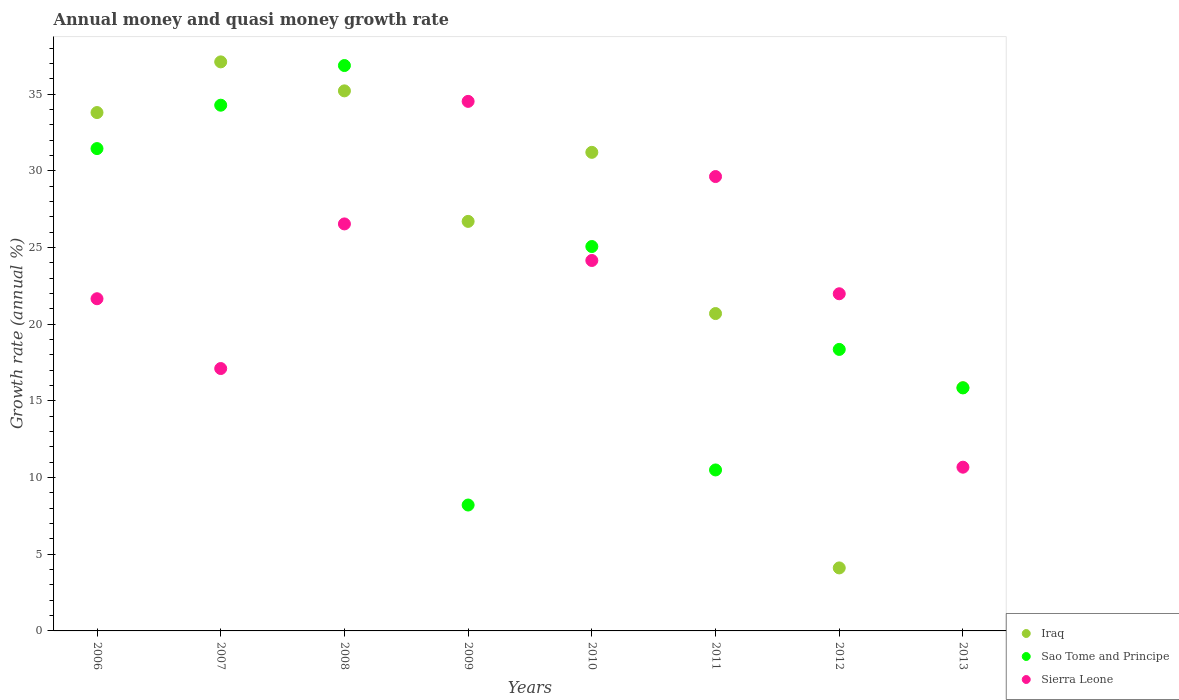Is the number of dotlines equal to the number of legend labels?
Offer a very short reply. Yes. What is the growth rate in Sierra Leone in 2006?
Your answer should be very brief. 21.66. Across all years, what is the maximum growth rate in Iraq?
Your response must be concise. 37.11. Across all years, what is the minimum growth rate in Sao Tome and Principe?
Keep it short and to the point. 8.21. In which year was the growth rate in Sao Tome and Principe maximum?
Keep it short and to the point. 2008. What is the total growth rate in Iraq in the graph?
Make the answer very short. 204.7. What is the difference between the growth rate in Sao Tome and Principe in 2007 and that in 2010?
Your response must be concise. 9.22. What is the difference between the growth rate in Sierra Leone in 2006 and the growth rate in Sao Tome and Principe in 2009?
Your answer should be very brief. 13.45. What is the average growth rate in Iraq per year?
Offer a terse response. 25.59. In the year 2011, what is the difference between the growth rate in Sierra Leone and growth rate in Iraq?
Your answer should be very brief. 8.93. In how many years, is the growth rate in Iraq greater than 10 %?
Make the answer very short. 7. What is the ratio of the growth rate in Iraq in 2008 to that in 2011?
Provide a succinct answer. 1.7. What is the difference between the highest and the second highest growth rate in Sierra Leone?
Make the answer very short. 4.9. What is the difference between the highest and the lowest growth rate in Iraq?
Give a very brief answer. 33. In how many years, is the growth rate in Sierra Leone greater than the average growth rate in Sierra Leone taken over all years?
Your response must be concise. 4. Is the sum of the growth rate in Iraq in 2008 and 2010 greater than the maximum growth rate in Sao Tome and Principe across all years?
Provide a short and direct response. Yes. Is it the case that in every year, the sum of the growth rate in Sierra Leone and growth rate in Sao Tome and Principe  is greater than the growth rate in Iraq?
Keep it short and to the point. Yes. Does the growth rate in Iraq monotonically increase over the years?
Provide a short and direct response. No. How many dotlines are there?
Your response must be concise. 3. Are the values on the major ticks of Y-axis written in scientific E-notation?
Your response must be concise. No. Does the graph contain grids?
Ensure brevity in your answer.  No. How are the legend labels stacked?
Your answer should be compact. Vertical. What is the title of the graph?
Provide a short and direct response. Annual money and quasi money growth rate. Does "Euro area" appear as one of the legend labels in the graph?
Give a very brief answer. No. What is the label or title of the X-axis?
Your answer should be compact. Years. What is the label or title of the Y-axis?
Offer a very short reply. Growth rate (annual %). What is the Growth rate (annual %) in Iraq in 2006?
Your answer should be compact. 33.8. What is the Growth rate (annual %) in Sao Tome and Principe in 2006?
Your response must be concise. 31.45. What is the Growth rate (annual %) in Sierra Leone in 2006?
Make the answer very short. 21.66. What is the Growth rate (annual %) of Iraq in 2007?
Offer a very short reply. 37.11. What is the Growth rate (annual %) of Sao Tome and Principe in 2007?
Give a very brief answer. 34.28. What is the Growth rate (annual %) in Sierra Leone in 2007?
Offer a very short reply. 17.11. What is the Growth rate (annual %) in Iraq in 2008?
Your response must be concise. 35.22. What is the Growth rate (annual %) in Sao Tome and Principe in 2008?
Your answer should be very brief. 36.87. What is the Growth rate (annual %) in Sierra Leone in 2008?
Offer a very short reply. 26.54. What is the Growth rate (annual %) in Iraq in 2009?
Provide a succinct answer. 26.7. What is the Growth rate (annual %) of Sao Tome and Principe in 2009?
Your answer should be compact. 8.21. What is the Growth rate (annual %) in Sierra Leone in 2009?
Offer a terse response. 34.53. What is the Growth rate (annual %) in Iraq in 2010?
Provide a succinct answer. 31.21. What is the Growth rate (annual %) of Sao Tome and Principe in 2010?
Make the answer very short. 25.06. What is the Growth rate (annual %) in Sierra Leone in 2010?
Offer a very short reply. 24.15. What is the Growth rate (annual %) of Iraq in 2011?
Provide a short and direct response. 20.69. What is the Growth rate (annual %) in Sao Tome and Principe in 2011?
Your answer should be very brief. 10.5. What is the Growth rate (annual %) in Sierra Leone in 2011?
Make the answer very short. 29.63. What is the Growth rate (annual %) of Iraq in 2012?
Offer a terse response. 4.11. What is the Growth rate (annual %) of Sao Tome and Principe in 2012?
Offer a very short reply. 18.36. What is the Growth rate (annual %) of Sierra Leone in 2012?
Your answer should be compact. 21.98. What is the Growth rate (annual %) of Iraq in 2013?
Give a very brief answer. 15.86. What is the Growth rate (annual %) in Sao Tome and Principe in 2013?
Make the answer very short. 15.85. What is the Growth rate (annual %) of Sierra Leone in 2013?
Your answer should be very brief. 10.68. Across all years, what is the maximum Growth rate (annual %) in Iraq?
Your answer should be very brief. 37.11. Across all years, what is the maximum Growth rate (annual %) of Sao Tome and Principe?
Give a very brief answer. 36.87. Across all years, what is the maximum Growth rate (annual %) of Sierra Leone?
Provide a short and direct response. 34.53. Across all years, what is the minimum Growth rate (annual %) of Iraq?
Give a very brief answer. 4.11. Across all years, what is the minimum Growth rate (annual %) of Sao Tome and Principe?
Offer a terse response. 8.21. Across all years, what is the minimum Growth rate (annual %) of Sierra Leone?
Your answer should be compact. 10.68. What is the total Growth rate (annual %) in Iraq in the graph?
Give a very brief answer. 204.7. What is the total Growth rate (annual %) of Sao Tome and Principe in the graph?
Your answer should be compact. 180.57. What is the total Growth rate (annual %) in Sierra Leone in the graph?
Your answer should be very brief. 186.28. What is the difference between the Growth rate (annual %) of Iraq in 2006 and that in 2007?
Your answer should be very brief. -3.3. What is the difference between the Growth rate (annual %) in Sao Tome and Principe in 2006 and that in 2007?
Your answer should be compact. -2.83. What is the difference between the Growth rate (annual %) of Sierra Leone in 2006 and that in 2007?
Provide a short and direct response. 4.55. What is the difference between the Growth rate (annual %) in Iraq in 2006 and that in 2008?
Ensure brevity in your answer.  -1.41. What is the difference between the Growth rate (annual %) in Sao Tome and Principe in 2006 and that in 2008?
Offer a terse response. -5.42. What is the difference between the Growth rate (annual %) of Sierra Leone in 2006 and that in 2008?
Your answer should be very brief. -4.88. What is the difference between the Growth rate (annual %) of Iraq in 2006 and that in 2009?
Provide a succinct answer. 7.1. What is the difference between the Growth rate (annual %) of Sao Tome and Principe in 2006 and that in 2009?
Provide a short and direct response. 23.24. What is the difference between the Growth rate (annual %) in Sierra Leone in 2006 and that in 2009?
Offer a very short reply. -12.87. What is the difference between the Growth rate (annual %) in Iraq in 2006 and that in 2010?
Make the answer very short. 2.59. What is the difference between the Growth rate (annual %) in Sao Tome and Principe in 2006 and that in 2010?
Offer a very short reply. 6.39. What is the difference between the Growth rate (annual %) of Sierra Leone in 2006 and that in 2010?
Provide a short and direct response. -2.49. What is the difference between the Growth rate (annual %) in Iraq in 2006 and that in 2011?
Provide a succinct answer. 13.11. What is the difference between the Growth rate (annual %) in Sao Tome and Principe in 2006 and that in 2011?
Provide a succinct answer. 20.95. What is the difference between the Growth rate (annual %) in Sierra Leone in 2006 and that in 2011?
Provide a short and direct response. -7.97. What is the difference between the Growth rate (annual %) in Iraq in 2006 and that in 2012?
Your answer should be compact. 29.69. What is the difference between the Growth rate (annual %) in Sao Tome and Principe in 2006 and that in 2012?
Give a very brief answer. 13.1. What is the difference between the Growth rate (annual %) of Sierra Leone in 2006 and that in 2012?
Provide a short and direct response. -0.32. What is the difference between the Growth rate (annual %) in Iraq in 2006 and that in 2013?
Provide a succinct answer. 17.94. What is the difference between the Growth rate (annual %) of Sao Tome and Principe in 2006 and that in 2013?
Ensure brevity in your answer.  15.6. What is the difference between the Growth rate (annual %) in Sierra Leone in 2006 and that in 2013?
Your answer should be compact. 10.98. What is the difference between the Growth rate (annual %) in Iraq in 2007 and that in 2008?
Provide a succinct answer. 1.89. What is the difference between the Growth rate (annual %) of Sao Tome and Principe in 2007 and that in 2008?
Make the answer very short. -2.59. What is the difference between the Growth rate (annual %) in Sierra Leone in 2007 and that in 2008?
Offer a very short reply. -9.43. What is the difference between the Growth rate (annual %) in Iraq in 2007 and that in 2009?
Offer a terse response. 10.4. What is the difference between the Growth rate (annual %) in Sao Tome and Principe in 2007 and that in 2009?
Offer a terse response. 26.07. What is the difference between the Growth rate (annual %) in Sierra Leone in 2007 and that in 2009?
Your answer should be compact. -17.42. What is the difference between the Growth rate (annual %) of Iraq in 2007 and that in 2010?
Keep it short and to the point. 5.9. What is the difference between the Growth rate (annual %) of Sao Tome and Principe in 2007 and that in 2010?
Your response must be concise. 9.22. What is the difference between the Growth rate (annual %) of Sierra Leone in 2007 and that in 2010?
Offer a terse response. -7.05. What is the difference between the Growth rate (annual %) in Iraq in 2007 and that in 2011?
Ensure brevity in your answer.  16.41. What is the difference between the Growth rate (annual %) of Sao Tome and Principe in 2007 and that in 2011?
Make the answer very short. 23.78. What is the difference between the Growth rate (annual %) in Sierra Leone in 2007 and that in 2011?
Give a very brief answer. -12.52. What is the difference between the Growth rate (annual %) in Iraq in 2007 and that in 2012?
Ensure brevity in your answer.  33. What is the difference between the Growth rate (annual %) of Sao Tome and Principe in 2007 and that in 2012?
Your answer should be very brief. 15.92. What is the difference between the Growth rate (annual %) in Sierra Leone in 2007 and that in 2012?
Ensure brevity in your answer.  -4.88. What is the difference between the Growth rate (annual %) of Iraq in 2007 and that in 2013?
Ensure brevity in your answer.  21.24. What is the difference between the Growth rate (annual %) in Sao Tome and Principe in 2007 and that in 2013?
Offer a very short reply. 18.43. What is the difference between the Growth rate (annual %) of Sierra Leone in 2007 and that in 2013?
Provide a short and direct response. 6.43. What is the difference between the Growth rate (annual %) in Iraq in 2008 and that in 2009?
Your answer should be compact. 8.51. What is the difference between the Growth rate (annual %) in Sao Tome and Principe in 2008 and that in 2009?
Make the answer very short. 28.66. What is the difference between the Growth rate (annual %) in Sierra Leone in 2008 and that in 2009?
Make the answer very short. -7.99. What is the difference between the Growth rate (annual %) in Iraq in 2008 and that in 2010?
Offer a terse response. 4.01. What is the difference between the Growth rate (annual %) in Sao Tome and Principe in 2008 and that in 2010?
Your answer should be compact. 11.8. What is the difference between the Growth rate (annual %) in Sierra Leone in 2008 and that in 2010?
Ensure brevity in your answer.  2.38. What is the difference between the Growth rate (annual %) in Iraq in 2008 and that in 2011?
Your response must be concise. 14.52. What is the difference between the Growth rate (annual %) in Sao Tome and Principe in 2008 and that in 2011?
Give a very brief answer. 26.37. What is the difference between the Growth rate (annual %) in Sierra Leone in 2008 and that in 2011?
Provide a succinct answer. -3.09. What is the difference between the Growth rate (annual %) in Iraq in 2008 and that in 2012?
Give a very brief answer. 31.11. What is the difference between the Growth rate (annual %) in Sao Tome and Principe in 2008 and that in 2012?
Provide a succinct answer. 18.51. What is the difference between the Growth rate (annual %) in Sierra Leone in 2008 and that in 2012?
Keep it short and to the point. 4.55. What is the difference between the Growth rate (annual %) in Iraq in 2008 and that in 2013?
Give a very brief answer. 19.35. What is the difference between the Growth rate (annual %) in Sao Tome and Principe in 2008 and that in 2013?
Your answer should be compact. 21.02. What is the difference between the Growth rate (annual %) of Sierra Leone in 2008 and that in 2013?
Offer a terse response. 15.86. What is the difference between the Growth rate (annual %) in Iraq in 2009 and that in 2010?
Offer a very short reply. -4.5. What is the difference between the Growth rate (annual %) of Sao Tome and Principe in 2009 and that in 2010?
Offer a terse response. -16.86. What is the difference between the Growth rate (annual %) in Sierra Leone in 2009 and that in 2010?
Your answer should be compact. 10.37. What is the difference between the Growth rate (annual %) in Iraq in 2009 and that in 2011?
Offer a very short reply. 6.01. What is the difference between the Growth rate (annual %) of Sao Tome and Principe in 2009 and that in 2011?
Give a very brief answer. -2.29. What is the difference between the Growth rate (annual %) of Sierra Leone in 2009 and that in 2011?
Make the answer very short. 4.9. What is the difference between the Growth rate (annual %) of Iraq in 2009 and that in 2012?
Your response must be concise. 22.6. What is the difference between the Growth rate (annual %) in Sao Tome and Principe in 2009 and that in 2012?
Give a very brief answer. -10.15. What is the difference between the Growth rate (annual %) in Sierra Leone in 2009 and that in 2012?
Your answer should be very brief. 12.54. What is the difference between the Growth rate (annual %) of Iraq in 2009 and that in 2013?
Your response must be concise. 10.84. What is the difference between the Growth rate (annual %) of Sao Tome and Principe in 2009 and that in 2013?
Ensure brevity in your answer.  -7.64. What is the difference between the Growth rate (annual %) of Sierra Leone in 2009 and that in 2013?
Ensure brevity in your answer.  23.85. What is the difference between the Growth rate (annual %) of Iraq in 2010 and that in 2011?
Your answer should be compact. 10.51. What is the difference between the Growth rate (annual %) in Sao Tome and Principe in 2010 and that in 2011?
Offer a terse response. 14.57. What is the difference between the Growth rate (annual %) of Sierra Leone in 2010 and that in 2011?
Offer a terse response. -5.47. What is the difference between the Growth rate (annual %) of Iraq in 2010 and that in 2012?
Ensure brevity in your answer.  27.1. What is the difference between the Growth rate (annual %) in Sao Tome and Principe in 2010 and that in 2012?
Provide a succinct answer. 6.71. What is the difference between the Growth rate (annual %) in Sierra Leone in 2010 and that in 2012?
Give a very brief answer. 2.17. What is the difference between the Growth rate (annual %) in Iraq in 2010 and that in 2013?
Your answer should be very brief. 15.34. What is the difference between the Growth rate (annual %) of Sao Tome and Principe in 2010 and that in 2013?
Offer a terse response. 9.22. What is the difference between the Growth rate (annual %) of Sierra Leone in 2010 and that in 2013?
Provide a short and direct response. 13.48. What is the difference between the Growth rate (annual %) of Iraq in 2011 and that in 2012?
Offer a terse response. 16.59. What is the difference between the Growth rate (annual %) of Sao Tome and Principe in 2011 and that in 2012?
Make the answer very short. -7.86. What is the difference between the Growth rate (annual %) of Sierra Leone in 2011 and that in 2012?
Provide a short and direct response. 7.64. What is the difference between the Growth rate (annual %) in Iraq in 2011 and that in 2013?
Your response must be concise. 4.83. What is the difference between the Growth rate (annual %) of Sao Tome and Principe in 2011 and that in 2013?
Give a very brief answer. -5.35. What is the difference between the Growth rate (annual %) in Sierra Leone in 2011 and that in 2013?
Offer a very short reply. 18.95. What is the difference between the Growth rate (annual %) of Iraq in 2012 and that in 2013?
Keep it short and to the point. -11.75. What is the difference between the Growth rate (annual %) in Sao Tome and Principe in 2012 and that in 2013?
Your response must be concise. 2.51. What is the difference between the Growth rate (annual %) in Sierra Leone in 2012 and that in 2013?
Provide a succinct answer. 11.31. What is the difference between the Growth rate (annual %) in Iraq in 2006 and the Growth rate (annual %) in Sao Tome and Principe in 2007?
Your answer should be compact. -0.48. What is the difference between the Growth rate (annual %) in Iraq in 2006 and the Growth rate (annual %) in Sierra Leone in 2007?
Offer a terse response. 16.69. What is the difference between the Growth rate (annual %) of Sao Tome and Principe in 2006 and the Growth rate (annual %) of Sierra Leone in 2007?
Provide a short and direct response. 14.34. What is the difference between the Growth rate (annual %) in Iraq in 2006 and the Growth rate (annual %) in Sao Tome and Principe in 2008?
Offer a very short reply. -3.07. What is the difference between the Growth rate (annual %) in Iraq in 2006 and the Growth rate (annual %) in Sierra Leone in 2008?
Provide a succinct answer. 7.26. What is the difference between the Growth rate (annual %) of Sao Tome and Principe in 2006 and the Growth rate (annual %) of Sierra Leone in 2008?
Provide a short and direct response. 4.91. What is the difference between the Growth rate (annual %) in Iraq in 2006 and the Growth rate (annual %) in Sao Tome and Principe in 2009?
Give a very brief answer. 25.59. What is the difference between the Growth rate (annual %) of Iraq in 2006 and the Growth rate (annual %) of Sierra Leone in 2009?
Keep it short and to the point. -0.73. What is the difference between the Growth rate (annual %) in Sao Tome and Principe in 2006 and the Growth rate (annual %) in Sierra Leone in 2009?
Your answer should be very brief. -3.08. What is the difference between the Growth rate (annual %) of Iraq in 2006 and the Growth rate (annual %) of Sao Tome and Principe in 2010?
Ensure brevity in your answer.  8.74. What is the difference between the Growth rate (annual %) of Iraq in 2006 and the Growth rate (annual %) of Sierra Leone in 2010?
Keep it short and to the point. 9.65. What is the difference between the Growth rate (annual %) of Sao Tome and Principe in 2006 and the Growth rate (annual %) of Sierra Leone in 2010?
Ensure brevity in your answer.  7.3. What is the difference between the Growth rate (annual %) of Iraq in 2006 and the Growth rate (annual %) of Sao Tome and Principe in 2011?
Your answer should be compact. 23.3. What is the difference between the Growth rate (annual %) in Iraq in 2006 and the Growth rate (annual %) in Sierra Leone in 2011?
Make the answer very short. 4.17. What is the difference between the Growth rate (annual %) of Sao Tome and Principe in 2006 and the Growth rate (annual %) of Sierra Leone in 2011?
Provide a succinct answer. 1.82. What is the difference between the Growth rate (annual %) of Iraq in 2006 and the Growth rate (annual %) of Sao Tome and Principe in 2012?
Provide a short and direct response. 15.44. What is the difference between the Growth rate (annual %) in Iraq in 2006 and the Growth rate (annual %) in Sierra Leone in 2012?
Give a very brief answer. 11.82. What is the difference between the Growth rate (annual %) in Sao Tome and Principe in 2006 and the Growth rate (annual %) in Sierra Leone in 2012?
Your answer should be very brief. 9.47. What is the difference between the Growth rate (annual %) of Iraq in 2006 and the Growth rate (annual %) of Sao Tome and Principe in 2013?
Make the answer very short. 17.95. What is the difference between the Growth rate (annual %) of Iraq in 2006 and the Growth rate (annual %) of Sierra Leone in 2013?
Offer a terse response. 23.12. What is the difference between the Growth rate (annual %) of Sao Tome and Principe in 2006 and the Growth rate (annual %) of Sierra Leone in 2013?
Give a very brief answer. 20.77. What is the difference between the Growth rate (annual %) in Iraq in 2007 and the Growth rate (annual %) in Sao Tome and Principe in 2008?
Keep it short and to the point. 0.24. What is the difference between the Growth rate (annual %) of Iraq in 2007 and the Growth rate (annual %) of Sierra Leone in 2008?
Provide a short and direct response. 10.57. What is the difference between the Growth rate (annual %) of Sao Tome and Principe in 2007 and the Growth rate (annual %) of Sierra Leone in 2008?
Your answer should be very brief. 7.74. What is the difference between the Growth rate (annual %) of Iraq in 2007 and the Growth rate (annual %) of Sao Tome and Principe in 2009?
Offer a terse response. 28.9. What is the difference between the Growth rate (annual %) of Iraq in 2007 and the Growth rate (annual %) of Sierra Leone in 2009?
Your response must be concise. 2.58. What is the difference between the Growth rate (annual %) of Sao Tome and Principe in 2007 and the Growth rate (annual %) of Sierra Leone in 2009?
Offer a terse response. -0.25. What is the difference between the Growth rate (annual %) of Iraq in 2007 and the Growth rate (annual %) of Sao Tome and Principe in 2010?
Your answer should be compact. 12.04. What is the difference between the Growth rate (annual %) of Iraq in 2007 and the Growth rate (annual %) of Sierra Leone in 2010?
Provide a succinct answer. 12.95. What is the difference between the Growth rate (annual %) in Sao Tome and Principe in 2007 and the Growth rate (annual %) in Sierra Leone in 2010?
Provide a short and direct response. 10.13. What is the difference between the Growth rate (annual %) in Iraq in 2007 and the Growth rate (annual %) in Sao Tome and Principe in 2011?
Provide a short and direct response. 26.61. What is the difference between the Growth rate (annual %) in Iraq in 2007 and the Growth rate (annual %) in Sierra Leone in 2011?
Keep it short and to the point. 7.48. What is the difference between the Growth rate (annual %) of Sao Tome and Principe in 2007 and the Growth rate (annual %) of Sierra Leone in 2011?
Ensure brevity in your answer.  4.65. What is the difference between the Growth rate (annual %) of Iraq in 2007 and the Growth rate (annual %) of Sao Tome and Principe in 2012?
Your answer should be very brief. 18.75. What is the difference between the Growth rate (annual %) in Iraq in 2007 and the Growth rate (annual %) in Sierra Leone in 2012?
Give a very brief answer. 15.12. What is the difference between the Growth rate (annual %) in Sao Tome and Principe in 2007 and the Growth rate (annual %) in Sierra Leone in 2012?
Your answer should be compact. 12.3. What is the difference between the Growth rate (annual %) of Iraq in 2007 and the Growth rate (annual %) of Sao Tome and Principe in 2013?
Make the answer very short. 21.26. What is the difference between the Growth rate (annual %) in Iraq in 2007 and the Growth rate (annual %) in Sierra Leone in 2013?
Your answer should be very brief. 26.43. What is the difference between the Growth rate (annual %) in Sao Tome and Principe in 2007 and the Growth rate (annual %) in Sierra Leone in 2013?
Give a very brief answer. 23.6. What is the difference between the Growth rate (annual %) of Iraq in 2008 and the Growth rate (annual %) of Sao Tome and Principe in 2009?
Provide a short and direct response. 27.01. What is the difference between the Growth rate (annual %) of Iraq in 2008 and the Growth rate (annual %) of Sierra Leone in 2009?
Your response must be concise. 0.69. What is the difference between the Growth rate (annual %) in Sao Tome and Principe in 2008 and the Growth rate (annual %) in Sierra Leone in 2009?
Offer a terse response. 2.34. What is the difference between the Growth rate (annual %) of Iraq in 2008 and the Growth rate (annual %) of Sao Tome and Principe in 2010?
Your answer should be compact. 10.15. What is the difference between the Growth rate (annual %) in Iraq in 2008 and the Growth rate (annual %) in Sierra Leone in 2010?
Ensure brevity in your answer.  11.06. What is the difference between the Growth rate (annual %) of Sao Tome and Principe in 2008 and the Growth rate (annual %) of Sierra Leone in 2010?
Offer a very short reply. 12.71. What is the difference between the Growth rate (annual %) of Iraq in 2008 and the Growth rate (annual %) of Sao Tome and Principe in 2011?
Your answer should be very brief. 24.72. What is the difference between the Growth rate (annual %) in Iraq in 2008 and the Growth rate (annual %) in Sierra Leone in 2011?
Give a very brief answer. 5.59. What is the difference between the Growth rate (annual %) in Sao Tome and Principe in 2008 and the Growth rate (annual %) in Sierra Leone in 2011?
Provide a short and direct response. 7.24. What is the difference between the Growth rate (annual %) in Iraq in 2008 and the Growth rate (annual %) in Sao Tome and Principe in 2012?
Give a very brief answer. 16.86. What is the difference between the Growth rate (annual %) of Iraq in 2008 and the Growth rate (annual %) of Sierra Leone in 2012?
Your answer should be compact. 13.23. What is the difference between the Growth rate (annual %) of Sao Tome and Principe in 2008 and the Growth rate (annual %) of Sierra Leone in 2012?
Ensure brevity in your answer.  14.88. What is the difference between the Growth rate (annual %) in Iraq in 2008 and the Growth rate (annual %) in Sao Tome and Principe in 2013?
Offer a very short reply. 19.37. What is the difference between the Growth rate (annual %) of Iraq in 2008 and the Growth rate (annual %) of Sierra Leone in 2013?
Provide a short and direct response. 24.54. What is the difference between the Growth rate (annual %) of Sao Tome and Principe in 2008 and the Growth rate (annual %) of Sierra Leone in 2013?
Ensure brevity in your answer.  26.19. What is the difference between the Growth rate (annual %) of Iraq in 2009 and the Growth rate (annual %) of Sao Tome and Principe in 2010?
Your answer should be compact. 1.64. What is the difference between the Growth rate (annual %) of Iraq in 2009 and the Growth rate (annual %) of Sierra Leone in 2010?
Provide a succinct answer. 2.55. What is the difference between the Growth rate (annual %) in Sao Tome and Principe in 2009 and the Growth rate (annual %) in Sierra Leone in 2010?
Your answer should be very brief. -15.95. What is the difference between the Growth rate (annual %) in Iraq in 2009 and the Growth rate (annual %) in Sao Tome and Principe in 2011?
Ensure brevity in your answer.  16.21. What is the difference between the Growth rate (annual %) of Iraq in 2009 and the Growth rate (annual %) of Sierra Leone in 2011?
Your response must be concise. -2.92. What is the difference between the Growth rate (annual %) of Sao Tome and Principe in 2009 and the Growth rate (annual %) of Sierra Leone in 2011?
Your response must be concise. -21.42. What is the difference between the Growth rate (annual %) of Iraq in 2009 and the Growth rate (annual %) of Sao Tome and Principe in 2012?
Provide a short and direct response. 8.35. What is the difference between the Growth rate (annual %) in Iraq in 2009 and the Growth rate (annual %) in Sierra Leone in 2012?
Your answer should be compact. 4.72. What is the difference between the Growth rate (annual %) of Sao Tome and Principe in 2009 and the Growth rate (annual %) of Sierra Leone in 2012?
Make the answer very short. -13.78. What is the difference between the Growth rate (annual %) in Iraq in 2009 and the Growth rate (annual %) in Sao Tome and Principe in 2013?
Offer a terse response. 10.86. What is the difference between the Growth rate (annual %) in Iraq in 2009 and the Growth rate (annual %) in Sierra Leone in 2013?
Offer a terse response. 16.03. What is the difference between the Growth rate (annual %) in Sao Tome and Principe in 2009 and the Growth rate (annual %) in Sierra Leone in 2013?
Ensure brevity in your answer.  -2.47. What is the difference between the Growth rate (annual %) of Iraq in 2010 and the Growth rate (annual %) of Sao Tome and Principe in 2011?
Your answer should be very brief. 20.71. What is the difference between the Growth rate (annual %) of Iraq in 2010 and the Growth rate (annual %) of Sierra Leone in 2011?
Ensure brevity in your answer.  1.58. What is the difference between the Growth rate (annual %) of Sao Tome and Principe in 2010 and the Growth rate (annual %) of Sierra Leone in 2011?
Make the answer very short. -4.56. What is the difference between the Growth rate (annual %) in Iraq in 2010 and the Growth rate (annual %) in Sao Tome and Principe in 2012?
Offer a very short reply. 12.85. What is the difference between the Growth rate (annual %) of Iraq in 2010 and the Growth rate (annual %) of Sierra Leone in 2012?
Your answer should be compact. 9.22. What is the difference between the Growth rate (annual %) of Sao Tome and Principe in 2010 and the Growth rate (annual %) of Sierra Leone in 2012?
Offer a terse response. 3.08. What is the difference between the Growth rate (annual %) of Iraq in 2010 and the Growth rate (annual %) of Sao Tome and Principe in 2013?
Ensure brevity in your answer.  15.36. What is the difference between the Growth rate (annual %) in Iraq in 2010 and the Growth rate (annual %) in Sierra Leone in 2013?
Ensure brevity in your answer.  20.53. What is the difference between the Growth rate (annual %) of Sao Tome and Principe in 2010 and the Growth rate (annual %) of Sierra Leone in 2013?
Provide a succinct answer. 14.39. What is the difference between the Growth rate (annual %) in Iraq in 2011 and the Growth rate (annual %) in Sao Tome and Principe in 2012?
Your answer should be compact. 2.34. What is the difference between the Growth rate (annual %) in Iraq in 2011 and the Growth rate (annual %) in Sierra Leone in 2012?
Ensure brevity in your answer.  -1.29. What is the difference between the Growth rate (annual %) of Sao Tome and Principe in 2011 and the Growth rate (annual %) of Sierra Leone in 2012?
Offer a terse response. -11.49. What is the difference between the Growth rate (annual %) in Iraq in 2011 and the Growth rate (annual %) in Sao Tome and Principe in 2013?
Offer a very short reply. 4.85. What is the difference between the Growth rate (annual %) of Iraq in 2011 and the Growth rate (annual %) of Sierra Leone in 2013?
Give a very brief answer. 10.02. What is the difference between the Growth rate (annual %) of Sao Tome and Principe in 2011 and the Growth rate (annual %) of Sierra Leone in 2013?
Provide a short and direct response. -0.18. What is the difference between the Growth rate (annual %) in Iraq in 2012 and the Growth rate (annual %) in Sao Tome and Principe in 2013?
Offer a very short reply. -11.74. What is the difference between the Growth rate (annual %) of Iraq in 2012 and the Growth rate (annual %) of Sierra Leone in 2013?
Keep it short and to the point. -6.57. What is the difference between the Growth rate (annual %) of Sao Tome and Principe in 2012 and the Growth rate (annual %) of Sierra Leone in 2013?
Give a very brief answer. 7.68. What is the average Growth rate (annual %) of Iraq per year?
Your response must be concise. 25.59. What is the average Growth rate (annual %) in Sao Tome and Principe per year?
Ensure brevity in your answer.  22.57. What is the average Growth rate (annual %) in Sierra Leone per year?
Provide a short and direct response. 23.29. In the year 2006, what is the difference between the Growth rate (annual %) in Iraq and Growth rate (annual %) in Sao Tome and Principe?
Give a very brief answer. 2.35. In the year 2006, what is the difference between the Growth rate (annual %) in Iraq and Growth rate (annual %) in Sierra Leone?
Provide a short and direct response. 12.14. In the year 2006, what is the difference between the Growth rate (annual %) of Sao Tome and Principe and Growth rate (annual %) of Sierra Leone?
Provide a succinct answer. 9.79. In the year 2007, what is the difference between the Growth rate (annual %) in Iraq and Growth rate (annual %) in Sao Tome and Principe?
Keep it short and to the point. 2.82. In the year 2007, what is the difference between the Growth rate (annual %) of Iraq and Growth rate (annual %) of Sierra Leone?
Your response must be concise. 20. In the year 2007, what is the difference between the Growth rate (annual %) of Sao Tome and Principe and Growth rate (annual %) of Sierra Leone?
Provide a short and direct response. 17.17. In the year 2008, what is the difference between the Growth rate (annual %) of Iraq and Growth rate (annual %) of Sao Tome and Principe?
Your answer should be compact. -1.65. In the year 2008, what is the difference between the Growth rate (annual %) of Iraq and Growth rate (annual %) of Sierra Leone?
Provide a short and direct response. 8.68. In the year 2008, what is the difference between the Growth rate (annual %) in Sao Tome and Principe and Growth rate (annual %) in Sierra Leone?
Your answer should be compact. 10.33. In the year 2009, what is the difference between the Growth rate (annual %) of Iraq and Growth rate (annual %) of Sao Tome and Principe?
Ensure brevity in your answer.  18.49. In the year 2009, what is the difference between the Growth rate (annual %) in Iraq and Growth rate (annual %) in Sierra Leone?
Offer a very short reply. -7.83. In the year 2009, what is the difference between the Growth rate (annual %) of Sao Tome and Principe and Growth rate (annual %) of Sierra Leone?
Make the answer very short. -26.32. In the year 2010, what is the difference between the Growth rate (annual %) in Iraq and Growth rate (annual %) in Sao Tome and Principe?
Make the answer very short. 6.14. In the year 2010, what is the difference between the Growth rate (annual %) in Iraq and Growth rate (annual %) in Sierra Leone?
Ensure brevity in your answer.  7.05. In the year 2010, what is the difference between the Growth rate (annual %) in Sao Tome and Principe and Growth rate (annual %) in Sierra Leone?
Your response must be concise. 0.91. In the year 2011, what is the difference between the Growth rate (annual %) in Iraq and Growth rate (annual %) in Sao Tome and Principe?
Provide a short and direct response. 10.2. In the year 2011, what is the difference between the Growth rate (annual %) of Iraq and Growth rate (annual %) of Sierra Leone?
Your answer should be compact. -8.93. In the year 2011, what is the difference between the Growth rate (annual %) of Sao Tome and Principe and Growth rate (annual %) of Sierra Leone?
Make the answer very short. -19.13. In the year 2012, what is the difference between the Growth rate (annual %) in Iraq and Growth rate (annual %) in Sao Tome and Principe?
Keep it short and to the point. -14.25. In the year 2012, what is the difference between the Growth rate (annual %) in Iraq and Growth rate (annual %) in Sierra Leone?
Your answer should be very brief. -17.88. In the year 2012, what is the difference between the Growth rate (annual %) in Sao Tome and Principe and Growth rate (annual %) in Sierra Leone?
Keep it short and to the point. -3.63. In the year 2013, what is the difference between the Growth rate (annual %) in Iraq and Growth rate (annual %) in Sao Tome and Principe?
Give a very brief answer. 0.02. In the year 2013, what is the difference between the Growth rate (annual %) of Iraq and Growth rate (annual %) of Sierra Leone?
Make the answer very short. 5.19. In the year 2013, what is the difference between the Growth rate (annual %) in Sao Tome and Principe and Growth rate (annual %) in Sierra Leone?
Give a very brief answer. 5.17. What is the ratio of the Growth rate (annual %) of Iraq in 2006 to that in 2007?
Offer a very short reply. 0.91. What is the ratio of the Growth rate (annual %) in Sao Tome and Principe in 2006 to that in 2007?
Offer a very short reply. 0.92. What is the ratio of the Growth rate (annual %) in Sierra Leone in 2006 to that in 2007?
Give a very brief answer. 1.27. What is the ratio of the Growth rate (annual %) of Iraq in 2006 to that in 2008?
Offer a very short reply. 0.96. What is the ratio of the Growth rate (annual %) of Sao Tome and Principe in 2006 to that in 2008?
Keep it short and to the point. 0.85. What is the ratio of the Growth rate (annual %) in Sierra Leone in 2006 to that in 2008?
Your response must be concise. 0.82. What is the ratio of the Growth rate (annual %) of Iraq in 2006 to that in 2009?
Provide a short and direct response. 1.27. What is the ratio of the Growth rate (annual %) of Sao Tome and Principe in 2006 to that in 2009?
Your response must be concise. 3.83. What is the ratio of the Growth rate (annual %) of Sierra Leone in 2006 to that in 2009?
Make the answer very short. 0.63. What is the ratio of the Growth rate (annual %) in Iraq in 2006 to that in 2010?
Give a very brief answer. 1.08. What is the ratio of the Growth rate (annual %) of Sao Tome and Principe in 2006 to that in 2010?
Keep it short and to the point. 1.25. What is the ratio of the Growth rate (annual %) in Sierra Leone in 2006 to that in 2010?
Provide a short and direct response. 0.9. What is the ratio of the Growth rate (annual %) of Iraq in 2006 to that in 2011?
Make the answer very short. 1.63. What is the ratio of the Growth rate (annual %) in Sao Tome and Principe in 2006 to that in 2011?
Your response must be concise. 3. What is the ratio of the Growth rate (annual %) of Sierra Leone in 2006 to that in 2011?
Give a very brief answer. 0.73. What is the ratio of the Growth rate (annual %) in Iraq in 2006 to that in 2012?
Your answer should be compact. 8.23. What is the ratio of the Growth rate (annual %) in Sao Tome and Principe in 2006 to that in 2012?
Your answer should be compact. 1.71. What is the ratio of the Growth rate (annual %) of Iraq in 2006 to that in 2013?
Ensure brevity in your answer.  2.13. What is the ratio of the Growth rate (annual %) of Sao Tome and Principe in 2006 to that in 2013?
Keep it short and to the point. 1.98. What is the ratio of the Growth rate (annual %) of Sierra Leone in 2006 to that in 2013?
Make the answer very short. 2.03. What is the ratio of the Growth rate (annual %) of Iraq in 2007 to that in 2008?
Ensure brevity in your answer.  1.05. What is the ratio of the Growth rate (annual %) of Sao Tome and Principe in 2007 to that in 2008?
Make the answer very short. 0.93. What is the ratio of the Growth rate (annual %) in Sierra Leone in 2007 to that in 2008?
Keep it short and to the point. 0.64. What is the ratio of the Growth rate (annual %) of Iraq in 2007 to that in 2009?
Offer a terse response. 1.39. What is the ratio of the Growth rate (annual %) in Sao Tome and Principe in 2007 to that in 2009?
Keep it short and to the point. 4.18. What is the ratio of the Growth rate (annual %) of Sierra Leone in 2007 to that in 2009?
Provide a short and direct response. 0.5. What is the ratio of the Growth rate (annual %) of Iraq in 2007 to that in 2010?
Keep it short and to the point. 1.19. What is the ratio of the Growth rate (annual %) in Sao Tome and Principe in 2007 to that in 2010?
Provide a succinct answer. 1.37. What is the ratio of the Growth rate (annual %) in Sierra Leone in 2007 to that in 2010?
Provide a short and direct response. 0.71. What is the ratio of the Growth rate (annual %) of Iraq in 2007 to that in 2011?
Keep it short and to the point. 1.79. What is the ratio of the Growth rate (annual %) in Sao Tome and Principe in 2007 to that in 2011?
Your response must be concise. 3.27. What is the ratio of the Growth rate (annual %) of Sierra Leone in 2007 to that in 2011?
Give a very brief answer. 0.58. What is the ratio of the Growth rate (annual %) of Iraq in 2007 to that in 2012?
Offer a very short reply. 9.03. What is the ratio of the Growth rate (annual %) of Sao Tome and Principe in 2007 to that in 2012?
Offer a terse response. 1.87. What is the ratio of the Growth rate (annual %) in Sierra Leone in 2007 to that in 2012?
Make the answer very short. 0.78. What is the ratio of the Growth rate (annual %) in Iraq in 2007 to that in 2013?
Your answer should be very brief. 2.34. What is the ratio of the Growth rate (annual %) in Sao Tome and Principe in 2007 to that in 2013?
Ensure brevity in your answer.  2.16. What is the ratio of the Growth rate (annual %) in Sierra Leone in 2007 to that in 2013?
Your answer should be compact. 1.6. What is the ratio of the Growth rate (annual %) in Iraq in 2008 to that in 2009?
Give a very brief answer. 1.32. What is the ratio of the Growth rate (annual %) in Sao Tome and Principe in 2008 to that in 2009?
Offer a terse response. 4.49. What is the ratio of the Growth rate (annual %) of Sierra Leone in 2008 to that in 2009?
Keep it short and to the point. 0.77. What is the ratio of the Growth rate (annual %) of Iraq in 2008 to that in 2010?
Provide a succinct answer. 1.13. What is the ratio of the Growth rate (annual %) of Sao Tome and Principe in 2008 to that in 2010?
Offer a very short reply. 1.47. What is the ratio of the Growth rate (annual %) in Sierra Leone in 2008 to that in 2010?
Offer a very short reply. 1.1. What is the ratio of the Growth rate (annual %) of Iraq in 2008 to that in 2011?
Provide a succinct answer. 1.7. What is the ratio of the Growth rate (annual %) in Sao Tome and Principe in 2008 to that in 2011?
Ensure brevity in your answer.  3.51. What is the ratio of the Growth rate (annual %) in Sierra Leone in 2008 to that in 2011?
Your answer should be compact. 0.9. What is the ratio of the Growth rate (annual %) in Iraq in 2008 to that in 2012?
Make the answer very short. 8.57. What is the ratio of the Growth rate (annual %) of Sao Tome and Principe in 2008 to that in 2012?
Offer a very short reply. 2.01. What is the ratio of the Growth rate (annual %) in Sierra Leone in 2008 to that in 2012?
Your response must be concise. 1.21. What is the ratio of the Growth rate (annual %) in Iraq in 2008 to that in 2013?
Your response must be concise. 2.22. What is the ratio of the Growth rate (annual %) of Sao Tome and Principe in 2008 to that in 2013?
Make the answer very short. 2.33. What is the ratio of the Growth rate (annual %) in Sierra Leone in 2008 to that in 2013?
Offer a terse response. 2.49. What is the ratio of the Growth rate (annual %) in Iraq in 2009 to that in 2010?
Offer a very short reply. 0.86. What is the ratio of the Growth rate (annual %) in Sao Tome and Principe in 2009 to that in 2010?
Ensure brevity in your answer.  0.33. What is the ratio of the Growth rate (annual %) in Sierra Leone in 2009 to that in 2010?
Ensure brevity in your answer.  1.43. What is the ratio of the Growth rate (annual %) of Iraq in 2009 to that in 2011?
Ensure brevity in your answer.  1.29. What is the ratio of the Growth rate (annual %) of Sao Tome and Principe in 2009 to that in 2011?
Provide a short and direct response. 0.78. What is the ratio of the Growth rate (annual %) in Sierra Leone in 2009 to that in 2011?
Your answer should be compact. 1.17. What is the ratio of the Growth rate (annual %) in Sao Tome and Principe in 2009 to that in 2012?
Give a very brief answer. 0.45. What is the ratio of the Growth rate (annual %) in Sierra Leone in 2009 to that in 2012?
Give a very brief answer. 1.57. What is the ratio of the Growth rate (annual %) of Iraq in 2009 to that in 2013?
Offer a terse response. 1.68. What is the ratio of the Growth rate (annual %) in Sao Tome and Principe in 2009 to that in 2013?
Your response must be concise. 0.52. What is the ratio of the Growth rate (annual %) of Sierra Leone in 2009 to that in 2013?
Offer a very short reply. 3.23. What is the ratio of the Growth rate (annual %) of Iraq in 2010 to that in 2011?
Make the answer very short. 1.51. What is the ratio of the Growth rate (annual %) in Sao Tome and Principe in 2010 to that in 2011?
Your answer should be very brief. 2.39. What is the ratio of the Growth rate (annual %) in Sierra Leone in 2010 to that in 2011?
Provide a succinct answer. 0.82. What is the ratio of the Growth rate (annual %) of Iraq in 2010 to that in 2012?
Your answer should be very brief. 7.6. What is the ratio of the Growth rate (annual %) in Sao Tome and Principe in 2010 to that in 2012?
Make the answer very short. 1.37. What is the ratio of the Growth rate (annual %) in Sierra Leone in 2010 to that in 2012?
Offer a terse response. 1.1. What is the ratio of the Growth rate (annual %) in Iraq in 2010 to that in 2013?
Offer a very short reply. 1.97. What is the ratio of the Growth rate (annual %) of Sao Tome and Principe in 2010 to that in 2013?
Your answer should be compact. 1.58. What is the ratio of the Growth rate (annual %) in Sierra Leone in 2010 to that in 2013?
Make the answer very short. 2.26. What is the ratio of the Growth rate (annual %) in Iraq in 2011 to that in 2012?
Your answer should be compact. 5.04. What is the ratio of the Growth rate (annual %) of Sao Tome and Principe in 2011 to that in 2012?
Your response must be concise. 0.57. What is the ratio of the Growth rate (annual %) of Sierra Leone in 2011 to that in 2012?
Offer a very short reply. 1.35. What is the ratio of the Growth rate (annual %) of Iraq in 2011 to that in 2013?
Your answer should be compact. 1.3. What is the ratio of the Growth rate (annual %) of Sao Tome and Principe in 2011 to that in 2013?
Provide a succinct answer. 0.66. What is the ratio of the Growth rate (annual %) in Sierra Leone in 2011 to that in 2013?
Offer a very short reply. 2.78. What is the ratio of the Growth rate (annual %) in Iraq in 2012 to that in 2013?
Offer a very short reply. 0.26. What is the ratio of the Growth rate (annual %) of Sao Tome and Principe in 2012 to that in 2013?
Offer a very short reply. 1.16. What is the ratio of the Growth rate (annual %) of Sierra Leone in 2012 to that in 2013?
Keep it short and to the point. 2.06. What is the difference between the highest and the second highest Growth rate (annual %) of Iraq?
Ensure brevity in your answer.  1.89. What is the difference between the highest and the second highest Growth rate (annual %) in Sao Tome and Principe?
Offer a very short reply. 2.59. What is the difference between the highest and the second highest Growth rate (annual %) of Sierra Leone?
Your response must be concise. 4.9. What is the difference between the highest and the lowest Growth rate (annual %) in Iraq?
Provide a short and direct response. 33. What is the difference between the highest and the lowest Growth rate (annual %) of Sao Tome and Principe?
Your answer should be very brief. 28.66. What is the difference between the highest and the lowest Growth rate (annual %) of Sierra Leone?
Keep it short and to the point. 23.85. 